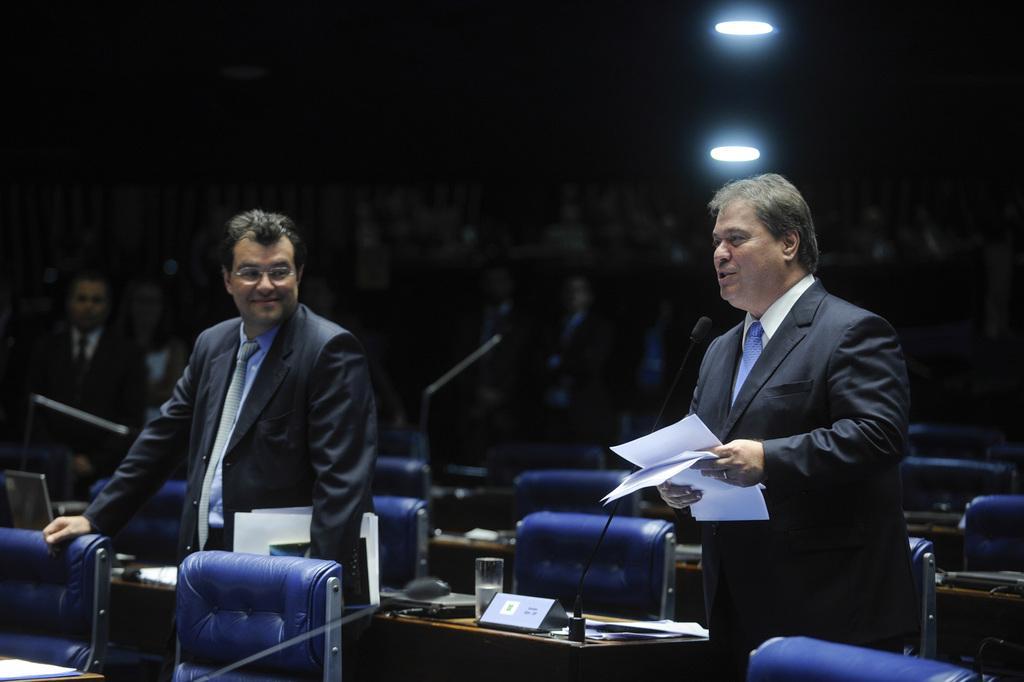Please provide a concise description of this image. In this image there are people standing and there are chairs, tables on that tables there are mike's, glasses, in the background it is blurred, at the top there are lights. 